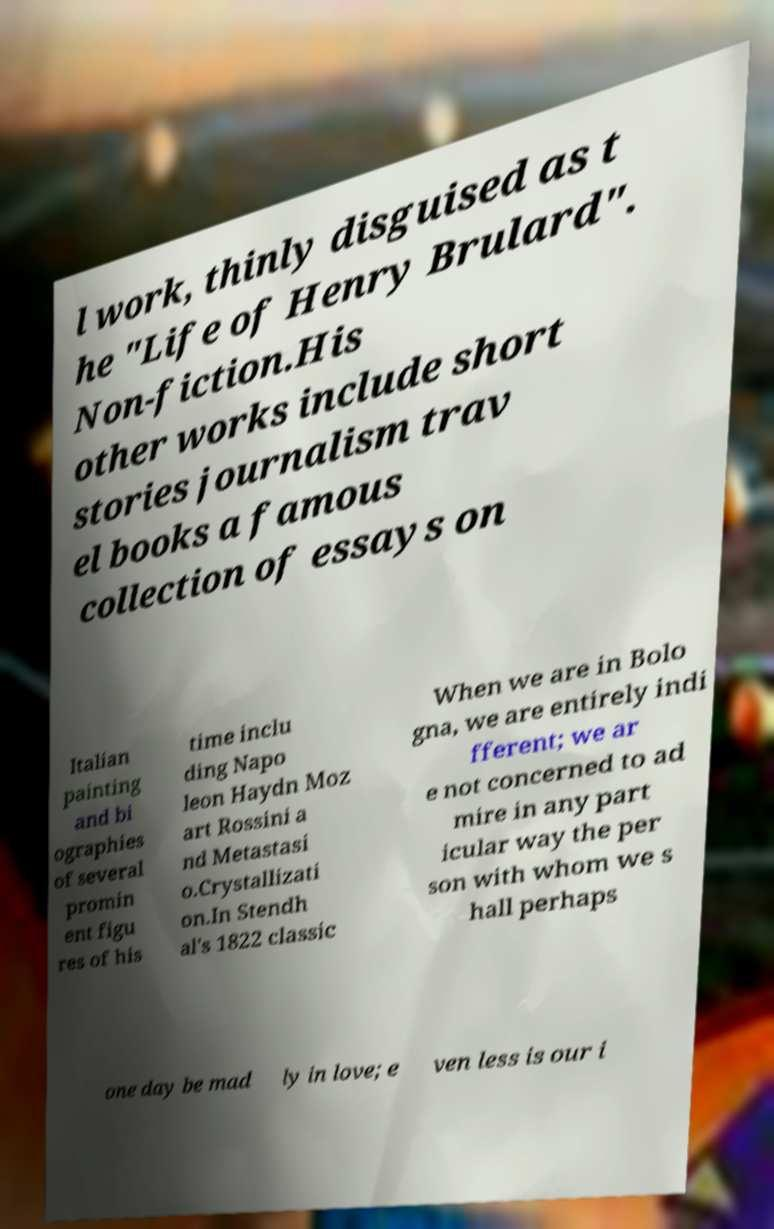I need the written content from this picture converted into text. Can you do that? l work, thinly disguised as t he "Life of Henry Brulard". Non-fiction.His other works include short stories journalism trav el books a famous collection of essays on Italian painting and bi ographies of several promin ent figu res of his time inclu ding Napo leon Haydn Moz art Rossini a nd Metastasi o.Crystallizati on.In Stendh al's 1822 classic When we are in Bolo gna, we are entirely indi fferent; we ar e not concerned to ad mire in any part icular way the per son with whom we s hall perhaps one day be mad ly in love; e ven less is our i 